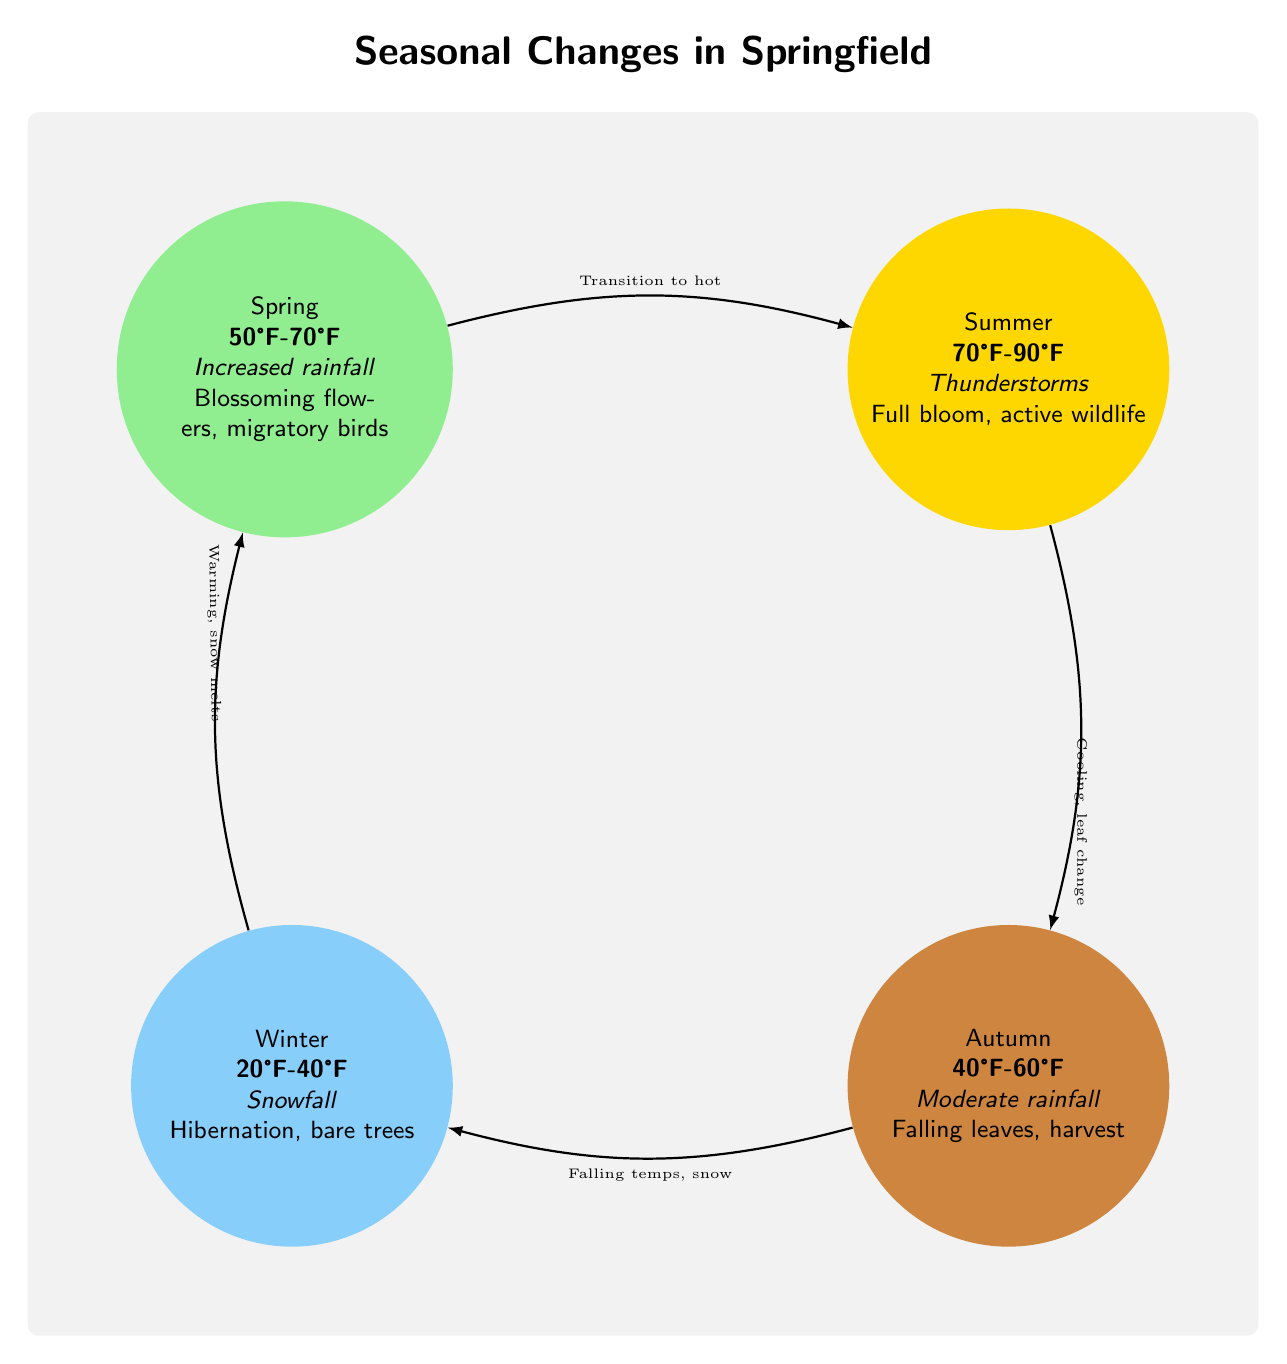What season has the highest temperature range? Summer has the highest temperature range of 70°F-90°F, which is detailed in the corresponding node of the diagram.
Answer: Summer What two seasons are connected by the transition labeled "Falling temps, snow"? The autumn and winter seasons are connected by this transition, as indicated in the diagram.
Answer: Autumn and Winter What is the temperature range for spring? The spring season is defined by a temperature range of 50°F-70°F, which is specified clearly in its node.
Answer: 50°F-70°F What effect on local fauna is observed during winter? The diagram mentions "Hibernation" as the effect on local fauna during winter, which is found in the winter season node.
Answer: Hibernation How many total seasons are illustrated in the diagram? There are four seasons illustrated in the diagram: spring, summer, autumn, and winter. This can be counted directly from the nodes.
Answer: Four What is the primary weather condition associated with summer? The primary weather condition linked to summer is "Thunderstorms," which is stated in the summer season node.
Answer: Thunderstorms What are the effects on local flora in autumn? The diagram notes "Falling leaves, harvest" as the effects on local flora during autumn. This information can be found in the autumn node.
Answer: Falling leaves, harvest What transition occurs between spring and summer? The transition labeled "Transition to hot" indicates the change occurring between spring and summer. This is explicitly outlined in the flow of the diagram.
Answer: Transition to hot What is the primary weather condition during winter? The primary weather condition during winter is "Snowfall," as described in the winter season node.
Answer: Snowfall 